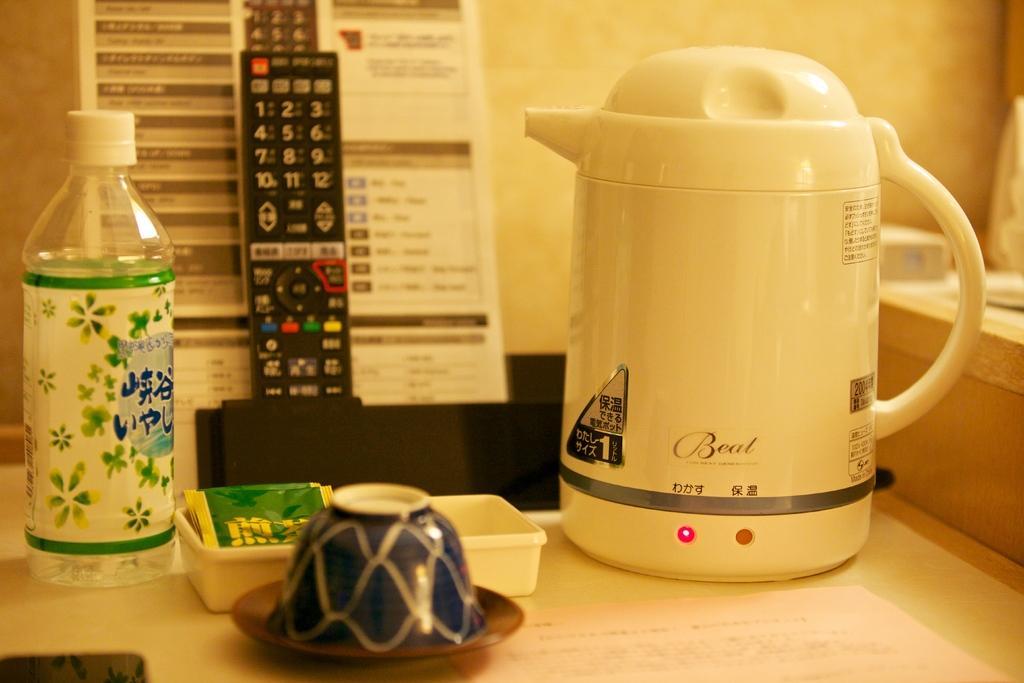Describe this image in one or two sentences. In this image there is a bottle, kettle, box, plate are on the table. Box is having some packets in it. Plate is having a bowl on it. There is a remote before a paper. Background there is a wall. 